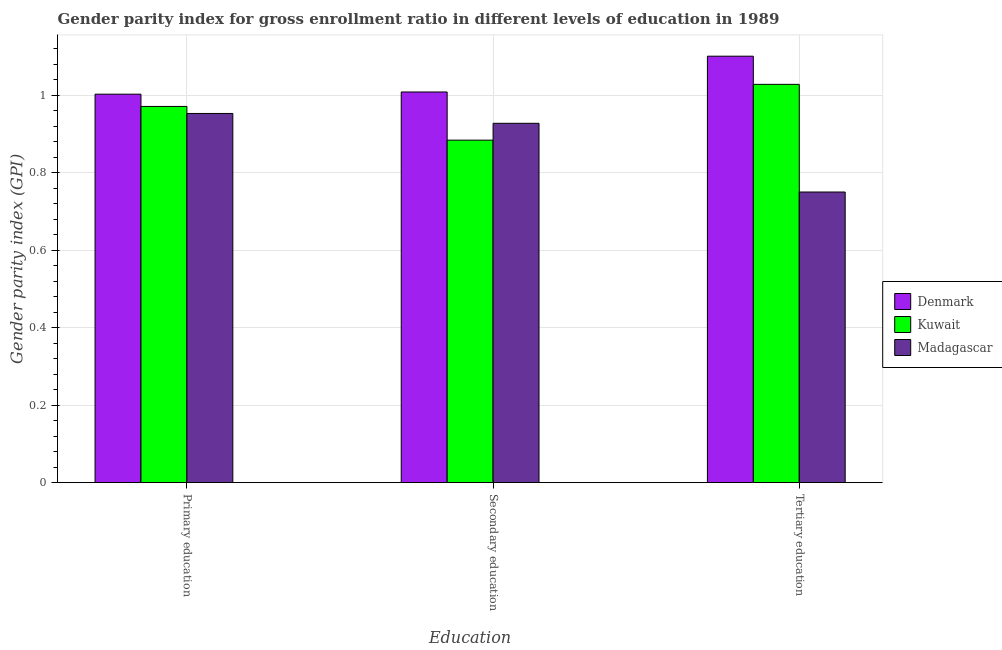How many groups of bars are there?
Ensure brevity in your answer.  3. What is the label of the 2nd group of bars from the left?
Offer a terse response. Secondary education. Across all countries, what is the maximum gender parity index in tertiary education?
Provide a succinct answer. 1.1. Across all countries, what is the minimum gender parity index in secondary education?
Your answer should be very brief. 0.88. In which country was the gender parity index in secondary education maximum?
Ensure brevity in your answer.  Denmark. In which country was the gender parity index in tertiary education minimum?
Offer a terse response. Madagascar. What is the total gender parity index in tertiary education in the graph?
Your answer should be compact. 2.88. What is the difference between the gender parity index in tertiary education in Madagascar and that in Denmark?
Your answer should be compact. -0.35. What is the difference between the gender parity index in secondary education in Madagascar and the gender parity index in tertiary education in Denmark?
Offer a very short reply. -0.17. What is the average gender parity index in secondary education per country?
Provide a short and direct response. 0.94. What is the difference between the gender parity index in tertiary education and gender parity index in secondary education in Denmark?
Your response must be concise. 0.09. What is the ratio of the gender parity index in tertiary education in Kuwait to that in Madagascar?
Your answer should be very brief. 1.37. Is the gender parity index in secondary education in Kuwait less than that in Madagascar?
Provide a succinct answer. Yes. Is the difference between the gender parity index in tertiary education in Denmark and Kuwait greater than the difference between the gender parity index in secondary education in Denmark and Kuwait?
Keep it short and to the point. No. What is the difference between the highest and the second highest gender parity index in tertiary education?
Provide a succinct answer. 0.07. What is the difference between the highest and the lowest gender parity index in primary education?
Your response must be concise. 0.05. In how many countries, is the gender parity index in tertiary education greater than the average gender parity index in tertiary education taken over all countries?
Offer a very short reply. 2. Is the sum of the gender parity index in primary education in Denmark and Kuwait greater than the maximum gender parity index in secondary education across all countries?
Provide a succinct answer. Yes. What does the 1st bar from the left in Primary education represents?
Offer a very short reply. Denmark. Is it the case that in every country, the sum of the gender parity index in primary education and gender parity index in secondary education is greater than the gender parity index in tertiary education?
Your answer should be compact. Yes. How many countries are there in the graph?
Your answer should be compact. 3. Are the values on the major ticks of Y-axis written in scientific E-notation?
Offer a very short reply. No. Does the graph contain grids?
Provide a succinct answer. Yes. How are the legend labels stacked?
Your answer should be very brief. Vertical. What is the title of the graph?
Your answer should be compact. Gender parity index for gross enrollment ratio in different levels of education in 1989. What is the label or title of the X-axis?
Your response must be concise. Education. What is the label or title of the Y-axis?
Provide a short and direct response. Gender parity index (GPI). What is the Gender parity index (GPI) of Kuwait in Primary education?
Your answer should be compact. 0.97. What is the Gender parity index (GPI) of Madagascar in Primary education?
Make the answer very short. 0.95. What is the Gender parity index (GPI) of Denmark in Secondary education?
Your answer should be very brief. 1.01. What is the Gender parity index (GPI) of Kuwait in Secondary education?
Provide a succinct answer. 0.88. What is the Gender parity index (GPI) of Madagascar in Secondary education?
Keep it short and to the point. 0.93. What is the Gender parity index (GPI) in Denmark in Tertiary education?
Your response must be concise. 1.1. What is the Gender parity index (GPI) in Kuwait in Tertiary education?
Keep it short and to the point. 1.03. What is the Gender parity index (GPI) of Madagascar in Tertiary education?
Offer a very short reply. 0.75. Across all Education, what is the maximum Gender parity index (GPI) of Denmark?
Your response must be concise. 1.1. Across all Education, what is the maximum Gender parity index (GPI) of Kuwait?
Offer a very short reply. 1.03. Across all Education, what is the maximum Gender parity index (GPI) in Madagascar?
Make the answer very short. 0.95. Across all Education, what is the minimum Gender parity index (GPI) of Denmark?
Ensure brevity in your answer.  1. Across all Education, what is the minimum Gender parity index (GPI) of Kuwait?
Your response must be concise. 0.88. Across all Education, what is the minimum Gender parity index (GPI) in Madagascar?
Ensure brevity in your answer.  0.75. What is the total Gender parity index (GPI) in Denmark in the graph?
Your answer should be compact. 3.11. What is the total Gender parity index (GPI) in Kuwait in the graph?
Offer a very short reply. 2.88. What is the total Gender parity index (GPI) of Madagascar in the graph?
Make the answer very short. 2.63. What is the difference between the Gender parity index (GPI) in Denmark in Primary education and that in Secondary education?
Offer a terse response. -0.01. What is the difference between the Gender parity index (GPI) in Kuwait in Primary education and that in Secondary education?
Your response must be concise. 0.09. What is the difference between the Gender parity index (GPI) of Madagascar in Primary education and that in Secondary education?
Offer a terse response. 0.03. What is the difference between the Gender parity index (GPI) in Denmark in Primary education and that in Tertiary education?
Your answer should be very brief. -0.1. What is the difference between the Gender parity index (GPI) of Kuwait in Primary education and that in Tertiary education?
Offer a terse response. -0.06. What is the difference between the Gender parity index (GPI) in Madagascar in Primary education and that in Tertiary education?
Offer a very short reply. 0.2. What is the difference between the Gender parity index (GPI) in Denmark in Secondary education and that in Tertiary education?
Ensure brevity in your answer.  -0.09. What is the difference between the Gender parity index (GPI) in Kuwait in Secondary education and that in Tertiary education?
Keep it short and to the point. -0.14. What is the difference between the Gender parity index (GPI) in Madagascar in Secondary education and that in Tertiary education?
Provide a short and direct response. 0.18. What is the difference between the Gender parity index (GPI) of Denmark in Primary education and the Gender parity index (GPI) of Kuwait in Secondary education?
Make the answer very short. 0.12. What is the difference between the Gender parity index (GPI) of Denmark in Primary education and the Gender parity index (GPI) of Madagascar in Secondary education?
Offer a very short reply. 0.08. What is the difference between the Gender parity index (GPI) of Kuwait in Primary education and the Gender parity index (GPI) of Madagascar in Secondary education?
Your response must be concise. 0.04. What is the difference between the Gender parity index (GPI) in Denmark in Primary education and the Gender parity index (GPI) in Kuwait in Tertiary education?
Ensure brevity in your answer.  -0.03. What is the difference between the Gender parity index (GPI) in Denmark in Primary education and the Gender parity index (GPI) in Madagascar in Tertiary education?
Make the answer very short. 0.25. What is the difference between the Gender parity index (GPI) of Kuwait in Primary education and the Gender parity index (GPI) of Madagascar in Tertiary education?
Give a very brief answer. 0.22. What is the difference between the Gender parity index (GPI) of Denmark in Secondary education and the Gender parity index (GPI) of Kuwait in Tertiary education?
Ensure brevity in your answer.  -0.02. What is the difference between the Gender parity index (GPI) in Denmark in Secondary education and the Gender parity index (GPI) in Madagascar in Tertiary education?
Provide a succinct answer. 0.26. What is the difference between the Gender parity index (GPI) in Kuwait in Secondary education and the Gender parity index (GPI) in Madagascar in Tertiary education?
Provide a short and direct response. 0.13. What is the average Gender parity index (GPI) in Denmark per Education?
Your response must be concise. 1.04. What is the average Gender parity index (GPI) in Kuwait per Education?
Give a very brief answer. 0.96. What is the average Gender parity index (GPI) of Madagascar per Education?
Provide a succinct answer. 0.88. What is the difference between the Gender parity index (GPI) of Denmark and Gender parity index (GPI) of Kuwait in Primary education?
Keep it short and to the point. 0.03. What is the difference between the Gender parity index (GPI) in Denmark and Gender parity index (GPI) in Madagascar in Primary education?
Ensure brevity in your answer.  0.05. What is the difference between the Gender parity index (GPI) of Kuwait and Gender parity index (GPI) of Madagascar in Primary education?
Make the answer very short. 0.02. What is the difference between the Gender parity index (GPI) of Denmark and Gender parity index (GPI) of Kuwait in Secondary education?
Ensure brevity in your answer.  0.12. What is the difference between the Gender parity index (GPI) of Denmark and Gender parity index (GPI) of Madagascar in Secondary education?
Your answer should be compact. 0.08. What is the difference between the Gender parity index (GPI) of Kuwait and Gender parity index (GPI) of Madagascar in Secondary education?
Provide a succinct answer. -0.04. What is the difference between the Gender parity index (GPI) in Denmark and Gender parity index (GPI) in Kuwait in Tertiary education?
Give a very brief answer. 0.07. What is the difference between the Gender parity index (GPI) in Denmark and Gender parity index (GPI) in Madagascar in Tertiary education?
Ensure brevity in your answer.  0.35. What is the difference between the Gender parity index (GPI) of Kuwait and Gender parity index (GPI) of Madagascar in Tertiary education?
Give a very brief answer. 0.28. What is the ratio of the Gender parity index (GPI) of Denmark in Primary education to that in Secondary education?
Provide a succinct answer. 0.99. What is the ratio of the Gender parity index (GPI) in Kuwait in Primary education to that in Secondary education?
Ensure brevity in your answer.  1.1. What is the ratio of the Gender parity index (GPI) of Madagascar in Primary education to that in Secondary education?
Offer a very short reply. 1.03. What is the ratio of the Gender parity index (GPI) in Denmark in Primary education to that in Tertiary education?
Ensure brevity in your answer.  0.91. What is the ratio of the Gender parity index (GPI) of Kuwait in Primary education to that in Tertiary education?
Offer a very short reply. 0.94. What is the ratio of the Gender parity index (GPI) of Madagascar in Primary education to that in Tertiary education?
Offer a terse response. 1.27. What is the ratio of the Gender parity index (GPI) of Denmark in Secondary education to that in Tertiary education?
Provide a succinct answer. 0.92. What is the ratio of the Gender parity index (GPI) of Kuwait in Secondary education to that in Tertiary education?
Your answer should be compact. 0.86. What is the ratio of the Gender parity index (GPI) in Madagascar in Secondary education to that in Tertiary education?
Offer a terse response. 1.24. What is the difference between the highest and the second highest Gender parity index (GPI) in Denmark?
Your response must be concise. 0.09. What is the difference between the highest and the second highest Gender parity index (GPI) in Kuwait?
Offer a very short reply. 0.06. What is the difference between the highest and the second highest Gender parity index (GPI) of Madagascar?
Your response must be concise. 0.03. What is the difference between the highest and the lowest Gender parity index (GPI) of Denmark?
Give a very brief answer. 0.1. What is the difference between the highest and the lowest Gender parity index (GPI) in Kuwait?
Keep it short and to the point. 0.14. What is the difference between the highest and the lowest Gender parity index (GPI) in Madagascar?
Offer a very short reply. 0.2. 